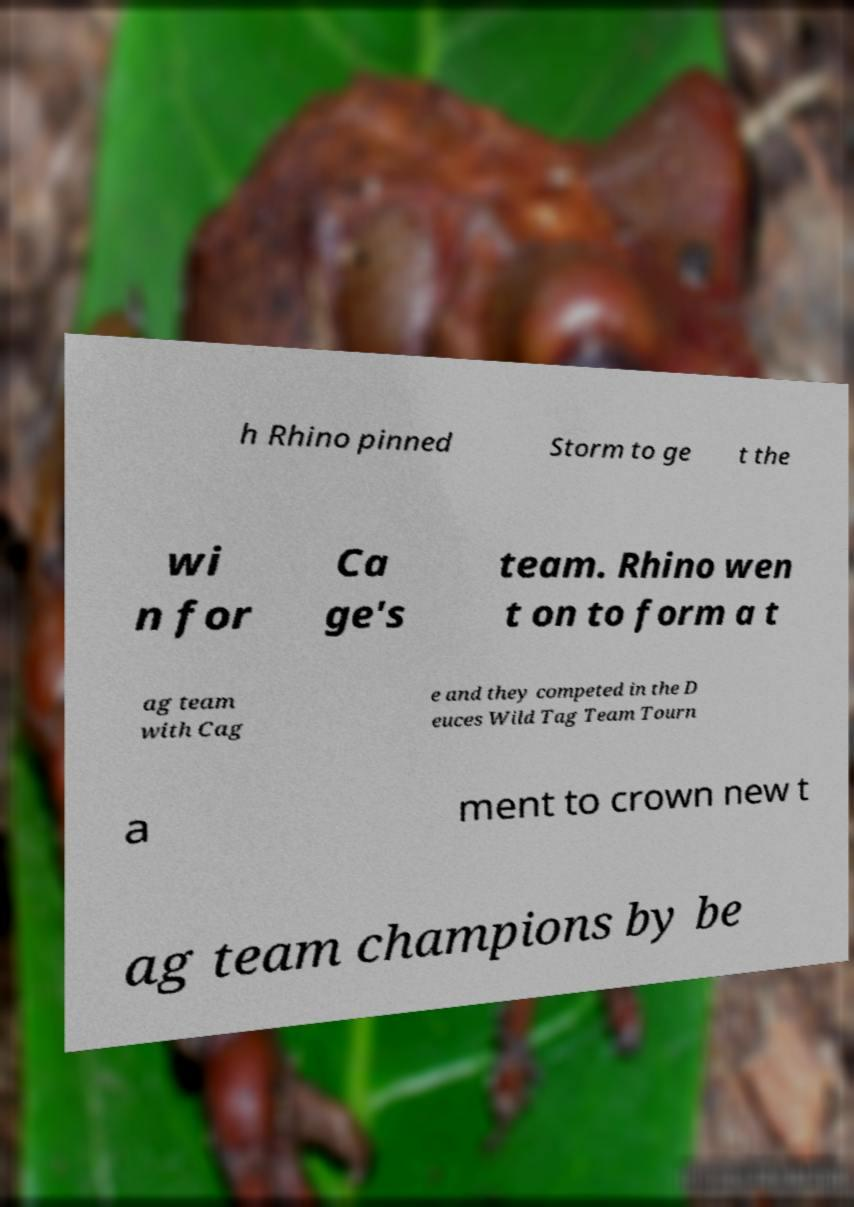Can you read and provide the text displayed in the image?This photo seems to have some interesting text. Can you extract and type it out for me? h Rhino pinned Storm to ge t the wi n for Ca ge's team. Rhino wen t on to form a t ag team with Cag e and they competed in the D euces Wild Tag Team Tourn a ment to crown new t ag team champions by be 